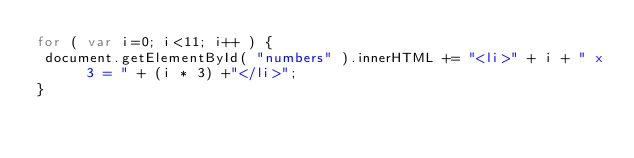<code> <loc_0><loc_0><loc_500><loc_500><_JavaScript_>for ( var i=0; i<11; i++ ) {
 document.getElementById( "numbers" ).innerHTML += "<li>" + i + " x 3 = " + (i * 3) +"</li>";
}
</code> 